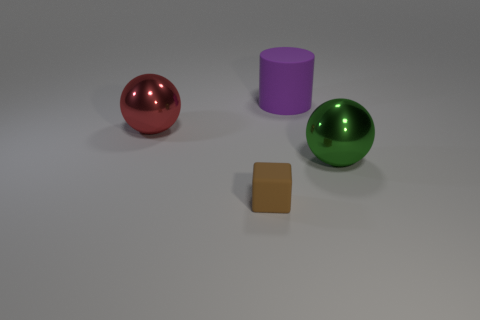What is the size of the rubber thing in front of the large shiny ball behind the green sphere?
Offer a terse response. Small. Is the number of metal spheres that are in front of the red metallic object greater than the number of cyan balls?
Keep it short and to the point. Yes. There is a metal thing to the left of the purple rubber object; is it the same size as the tiny block?
Ensure brevity in your answer.  No. What color is the object that is on the left side of the big cylinder and in front of the large red thing?
Your answer should be compact. Brown. The red object that is the same size as the cylinder is what shape?
Your answer should be very brief. Sphere. Are there any things that have the same color as the matte cylinder?
Your answer should be very brief. No. Are there the same number of large purple objects that are left of the large red object and red matte cylinders?
Your answer should be very brief. Yes. There is a object that is both in front of the red metallic sphere and left of the big cylinder; what is its size?
Offer a very short reply. Small. What is the color of the big object that is made of the same material as the tiny brown cube?
Provide a short and direct response. Purple. How many balls are the same material as the tiny brown block?
Make the answer very short. 0. 